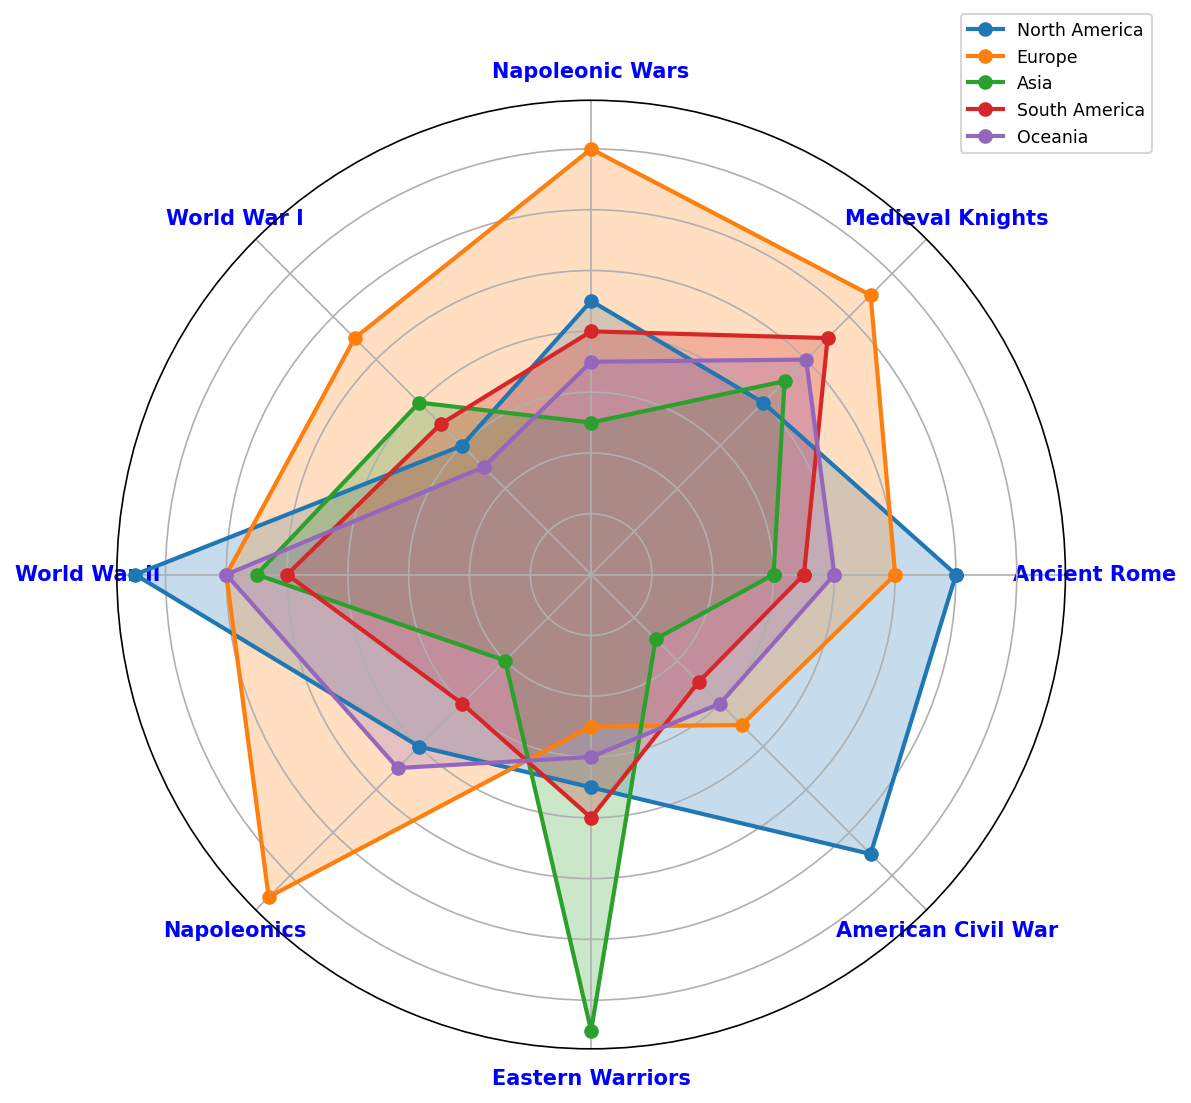What is the most preferred historical figurine subject in North America? Looking at the North America plot, we see that the highest point is at "World War II" with a value of 0.75. This indicates the most preferred historical figurine subject in North America.
Answer: World War II Which region has the least preference for American Civil War figurines? Observing the plots, Asia has the lowest point at "American Civil War" with a value of 0.15, compared to other regions.
Answer: Asia Which two regions have the highest preference for Napoleonic Wars figurines? By comparing the values at "Napoleonic Wars" across the regions, both Europe and North America show high preferences with values of 0.70 and 0.45 respectively. However, Europe has the highest preference, and North America follows.
Answer: Europe, North America Is the preference for Medieval Knights higher in Europe or Oceania? The value for "Medieval Knights" is higher in Europe (0.65) compared to Oceania (0.50).
Answer: Europe What is the difference in preference for Eastern Warriors between Asia and North America? For "Eastern Warriors", Asia has a preference value of 0.75, and North America has 0.35. The difference is calculated as 0.75 - 0.35 = 0.40.
Answer: 0.40 Which region shows nearly equal preference for Ancient Rome and World War I figurines? South America has preference values of 0.35 for both "Ancient Rome" and World War I, indicating nearly equal preference.
Answer: South America What is the average preference value for Napoleonic Wars across all regions? Sum of the "Napoleonic Wars" values across regions is 0.45 + 0.70 + 0.25 + 0.40 + 0.35 = 2.15. Divide this by the number of regions (5) to get the average: 2.15 / 5 = 0.43.
Answer: 0.43 Which region's preference pattern shows the least variation in historical periods? By observing the variances visually, North America's preferences tend to be more evenly distributed without extreme peaks and valleys, indicating the least variation.
Answer: North America How does South America's preference for World War II compare against the preference for Napoleonic Wars in Asia? South America's preference for "World War II" is 0.50, while Asia's preference for "Napoleonic Wars" is 0.25. South America's preference is higher by 0.50 - 0.25 = 0.25.
Answer: South America, 0.25 